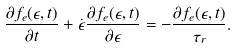Convert formula to latex. <formula><loc_0><loc_0><loc_500><loc_500>\frac { { \partial } f _ { e } ( \epsilon , t ) } { \partial t } + \dot { \epsilon } \frac { { \partial } f _ { e } ( \epsilon , t ) } { \partial \epsilon } = - \frac { { \partial } f _ { e } ( \epsilon , t ) } { \tau _ { r } } .</formula> 